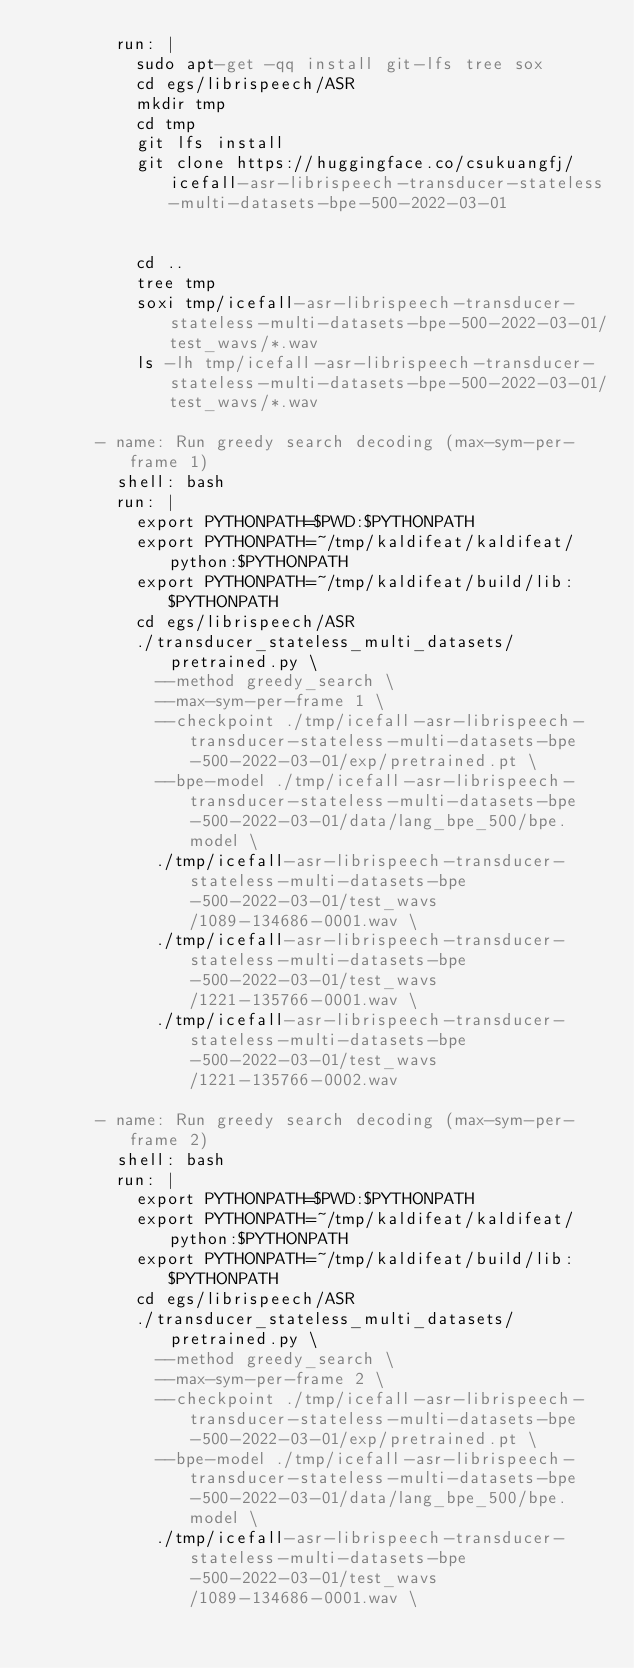Convert code to text. <code><loc_0><loc_0><loc_500><loc_500><_YAML_>        run: |
          sudo apt-get -qq install git-lfs tree sox
          cd egs/librispeech/ASR
          mkdir tmp
          cd tmp
          git lfs install
          git clone https://huggingface.co/csukuangfj/icefall-asr-librispeech-transducer-stateless-multi-datasets-bpe-500-2022-03-01


          cd ..
          tree tmp
          soxi tmp/icefall-asr-librispeech-transducer-stateless-multi-datasets-bpe-500-2022-03-01/test_wavs/*.wav
          ls -lh tmp/icefall-asr-librispeech-transducer-stateless-multi-datasets-bpe-500-2022-03-01/test_wavs/*.wav

      - name: Run greedy search decoding (max-sym-per-frame 1)
        shell: bash
        run: |
          export PYTHONPATH=$PWD:$PYTHONPATH
          export PYTHONPATH=~/tmp/kaldifeat/kaldifeat/python:$PYTHONPATH
          export PYTHONPATH=~/tmp/kaldifeat/build/lib:$PYTHONPATH
          cd egs/librispeech/ASR
          ./transducer_stateless_multi_datasets/pretrained.py \
            --method greedy_search \
            --max-sym-per-frame 1 \
            --checkpoint ./tmp/icefall-asr-librispeech-transducer-stateless-multi-datasets-bpe-500-2022-03-01/exp/pretrained.pt \
            --bpe-model ./tmp/icefall-asr-librispeech-transducer-stateless-multi-datasets-bpe-500-2022-03-01/data/lang_bpe_500/bpe.model \
            ./tmp/icefall-asr-librispeech-transducer-stateless-multi-datasets-bpe-500-2022-03-01/test_wavs/1089-134686-0001.wav \
            ./tmp/icefall-asr-librispeech-transducer-stateless-multi-datasets-bpe-500-2022-03-01/test_wavs/1221-135766-0001.wav \
            ./tmp/icefall-asr-librispeech-transducer-stateless-multi-datasets-bpe-500-2022-03-01/test_wavs/1221-135766-0002.wav

      - name: Run greedy search decoding (max-sym-per-frame 2)
        shell: bash
        run: |
          export PYTHONPATH=$PWD:$PYTHONPATH
          export PYTHONPATH=~/tmp/kaldifeat/kaldifeat/python:$PYTHONPATH
          export PYTHONPATH=~/tmp/kaldifeat/build/lib:$PYTHONPATH
          cd egs/librispeech/ASR
          ./transducer_stateless_multi_datasets/pretrained.py \
            --method greedy_search \
            --max-sym-per-frame 2 \
            --checkpoint ./tmp/icefall-asr-librispeech-transducer-stateless-multi-datasets-bpe-500-2022-03-01/exp/pretrained.pt \
            --bpe-model ./tmp/icefall-asr-librispeech-transducer-stateless-multi-datasets-bpe-500-2022-03-01/data/lang_bpe_500/bpe.model \
            ./tmp/icefall-asr-librispeech-transducer-stateless-multi-datasets-bpe-500-2022-03-01/test_wavs/1089-134686-0001.wav \</code> 